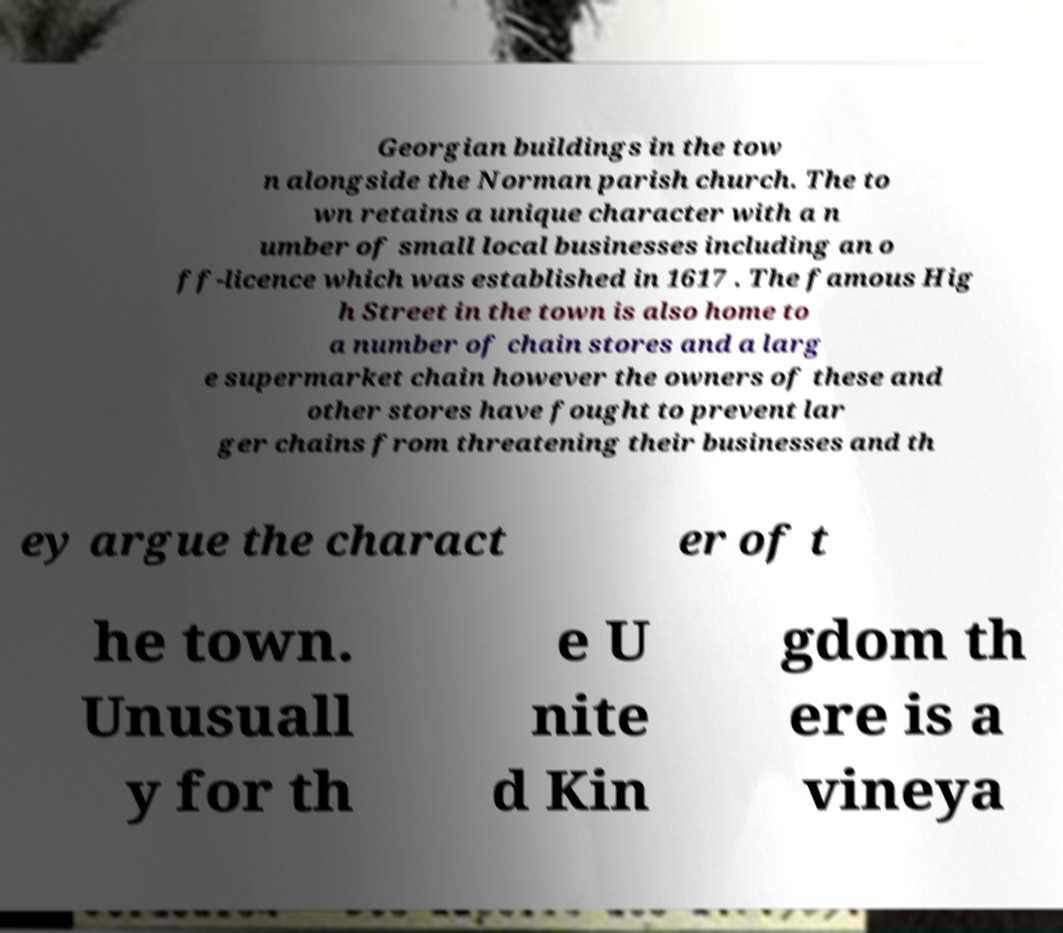For documentation purposes, I need the text within this image transcribed. Could you provide that? Georgian buildings in the tow n alongside the Norman parish church. The to wn retains a unique character with a n umber of small local businesses including an o ff-licence which was established in 1617 . The famous Hig h Street in the town is also home to a number of chain stores and a larg e supermarket chain however the owners of these and other stores have fought to prevent lar ger chains from threatening their businesses and th ey argue the charact er of t he town. Unusuall y for th e U nite d Kin gdom th ere is a vineya 